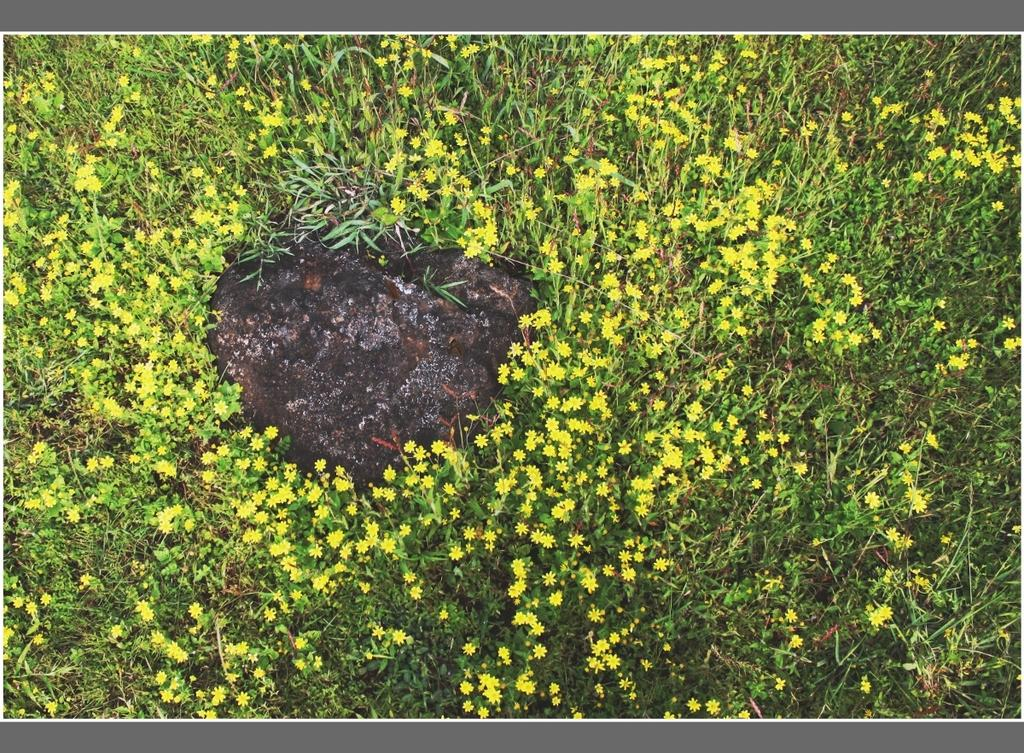What type of plants can be seen in the image? There are flower plants in the image. What type of knife is being used to cut the mother's appliance in the image? There is no knife, mother, or appliance present in the image; it only features flower plants. 